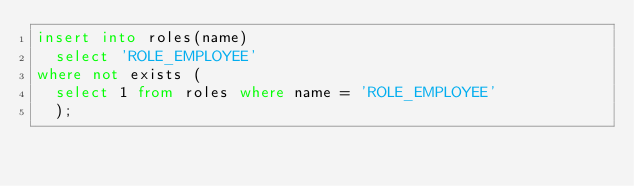Convert code to text. <code><loc_0><loc_0><loc_500><loc_500><_SQL_>insert into roles(name)
  select 'ROLE_EMPLOYEE'
where not exists (
  select 1 from roles where name = 'ROLE_EMPLOYEE'
  );</code> 